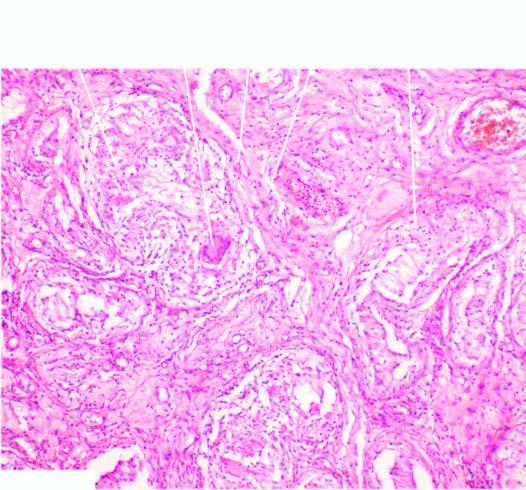what are surrounded by langhans 'giant cells and mantle of lymphocytes?
Answer the question using a single word or phrase. Granulomas 